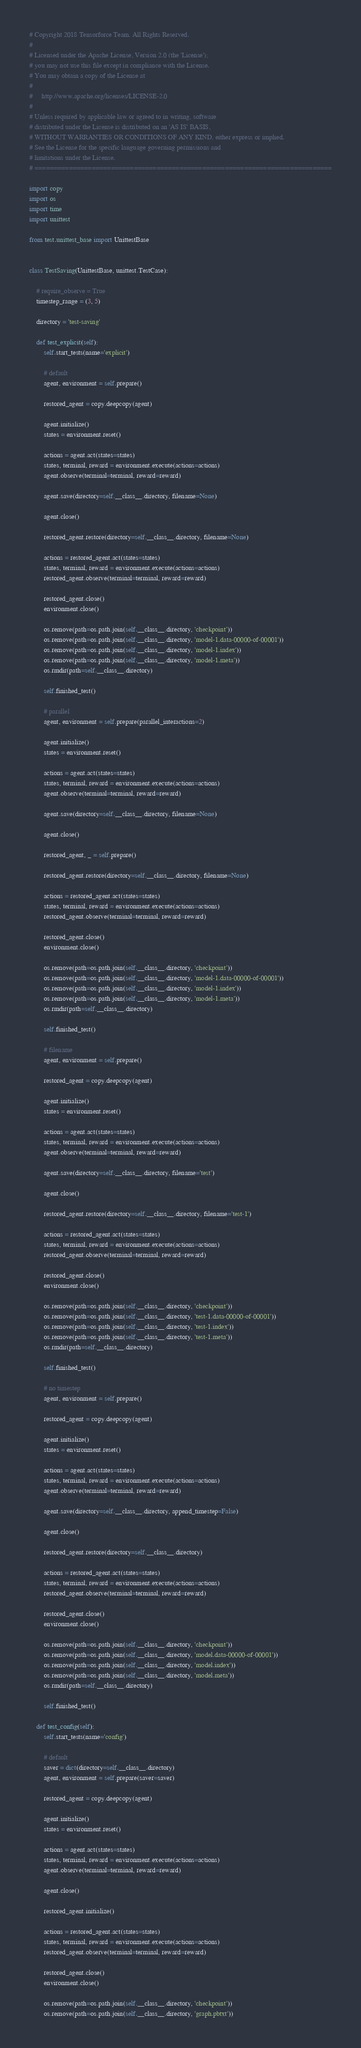Convert code to text. <code><loc_0><loc_0><loc_500><loc_500><_Python_># Copyright 2018 Tensorforce Team. All Rights Reserved.
#
# Licensed under the Apache License, Version 2.0 (the 'License');
# you may not use this file except in compliance with the License.
# You may obtain a copy of the License at
#
#     http://www.apache.org/licenses/LICENSE-2.0
#
# Unless required by applicable law or agreed to in writing, software
# distributed under the License is distributed on an 'AS IS' BASIS,
# WITHOUT WARRANTIES OR CONDITIONS OF ANY KIND, either express or implied.
# See the License for the specific language governing permissions and
# limitations under the License.
# ==============================================================================

import copy
import os
import time
import unittest

from test.unittest_base import UnittestBase


class TestSaving(UnittestBase, unittest.TestCase):

    # require_observe = True
    timestep_range = (3, 5)

    directory = 'test-saving'

    def test_explicit(self):
        self.start_tests(name='explicit')

        # default
        agent, environment = self.prepare()

        restored_agent = copy.deepcopy(agent)

        agent.initialize()
        states = environment.reset()

        actions = agent.act(states=states)
        states, terminal, reward = environment.execute(actions=actions)
        agent.observe(terminal=terminal, reward=reward)

        agent.save(directory=self.__class__.directory, filename=None)

        agent.close()

        restored_agent.restore(directory=self.__class__.directory, filename=None)

        actions = restored_agent.act(states=states)
        states, terminal, reward = environment.execute(actions=actions)
        restored_agent.observe(terminal=terminal, reward=reward)

        restored_agent.close()
        environment.close()

        os.remove(path=os.path.join(self.__class__.directory, 'checkpoint'))
        os.remove(path=os.path.join(self.__class__.directory, 'model-1.data-00000-of-00001'))
        os.remove(path=os.path.join(self.__class__.directory, 'model-1.index'))
        os.remove(path=os.path.join(self.__class__.directory, 'model-1.meta'))
        os.rmdir(path=self.__class__.directory)

        self.finished_test()

        # parallel
        agent, environment = self.prepare(parallel_interactions=2)

        agent.initialize()
        states = environment.reset()

        actions = agent.act(states=states)
        states, terminal, reward = environment.execute(actions=actions)
        agent.observe(terminal=terminal, reward=reward)

        agent.save(directory=self.__class__.directory, filename=None)

        agent.close()

        restored_agent, _ = self.prepare()

        restored_agent.restore(directory=self.__class__.directory, filename=None)

        actions = restored_agent.act(states=states)
        states, terminal, reward = environment.execute(actions=actions)
        restored_agent.observe(terminal=terminal, reward=reward)

        restored_agent.close()
        environment.close()

        os.remove(path=os.path.join(self.__class__.directory, 'checkpoint'))
        os.remove(path=os.path.join(self.__class__.directory, 'model-1.data-00000-of-00001'))
        os.remove(path=os.path.join(self.__class__.directory, 'model-1.index'))
        os.remove(path=os.path.join(self.__class__.directory, 'model-1.meta'))
        os.rmdir(path=self.__class__.directory)

        self.finished_test()

        # filename
        agent, environment = self.prepare()

        restored_agent = copy.deepcopy(agent)

        agent.initialize()
        states = environment.reset()

        actions = agent.act(states=states)
        states, terminal, reward = environment.execute(actions=actions)
        agent.observe(terminal=terminal, reward=reward)

        agent.save(directory=self.__class__.directory, filename='test')

        agent.close()

        restored_agent.restore(directory=self.__class__.directory, filename='test-1')

        actions = restored_agent.act(states=states)
        states, terminal, reward = environment.execute(actions=actions)
        restored_agent.observe(terminal=terminal, reward=reward)

        restored_agent.close()
        environment.close()

        os.remove(path=os.path.join(self.__class__.directory, 'checkpoint'))
        os.remove(path=os.path.join(self.__class__.directory, 'test-1.data-00000-of-00001'))
        os.remove(path=os.path.join(self.__class__.directory, 'test-1.index'))
        os.remove(path=os.path.join(self.__class__.directory, 'test-1.meta'))
        os.rmdir(path=self.__class__.directory)

        self.finished_test()

        # no timestep
        agent, environment = self.prepare()

        restored_agent = copy.deepcopy(agent)

        agent.initialize()
        states = environment.reset()

        actions = agent.act(states=states)
        states, terminal, reward = environment.execute(actions=actions)
        agent.observe(terminal=terminal, reward=reward)

        agent.save(directory=self.__class__.directory, append_timestep=False)

        agent.close()

        restored_agent.restore(directory=self.__class__.directory)

        actions = restored_agent.act(states=states)
        states, terminal, reward = environment.execute(actions=actions)
        restored_agent.observe(terminal=terminal, reward=reward)

        restored_agent.close()
        environment.close()

        os.remove(path=os.path.join(self.__class__.directory, 'checkpoint'))
        os.remove(path=os.path.join(self.__class__.directory, 'model.data-00000-of-00001'))
        os.remove(path=os.path.join(self.__class__.directory, 'model.index'))
        os.remove(path=os.path.join(self.__class__.directory, 'model.meta'))
        os.rmdir(path=self.__class__.directory)

        self.finished_test()

    def test_config(self):
        self.start_tests(name='config')

        # default
        saver = dict(directory=self.__class__.directory)
        agent, environment = self.prepare(saver=saver)

        restored_agent = copy.deepcopy(agent)

        agent.initialize()
        states = environment.reset()

        actions = agent.act(states=states)
        states, terminal, reward = environment.execute(actions=actions)
        agent.observe(terminal=terminal, reward=reward)

        agent.close()

        restored_agent.initialize()

        actions = restored_agent.act(states=states)
        states, terminal, reward = environment.execute(actions=actions)
        restored_agent.observe(terminal=terminal, reward=reward)

        restored_agent.close()
        environment.close()

        os.remove(path=os.path.join(self.__class__.directory, 'checkpoint'))
        os.remove(path=os.path.join(self.__class__.directory, 'graph.pbtxt'))</code> 